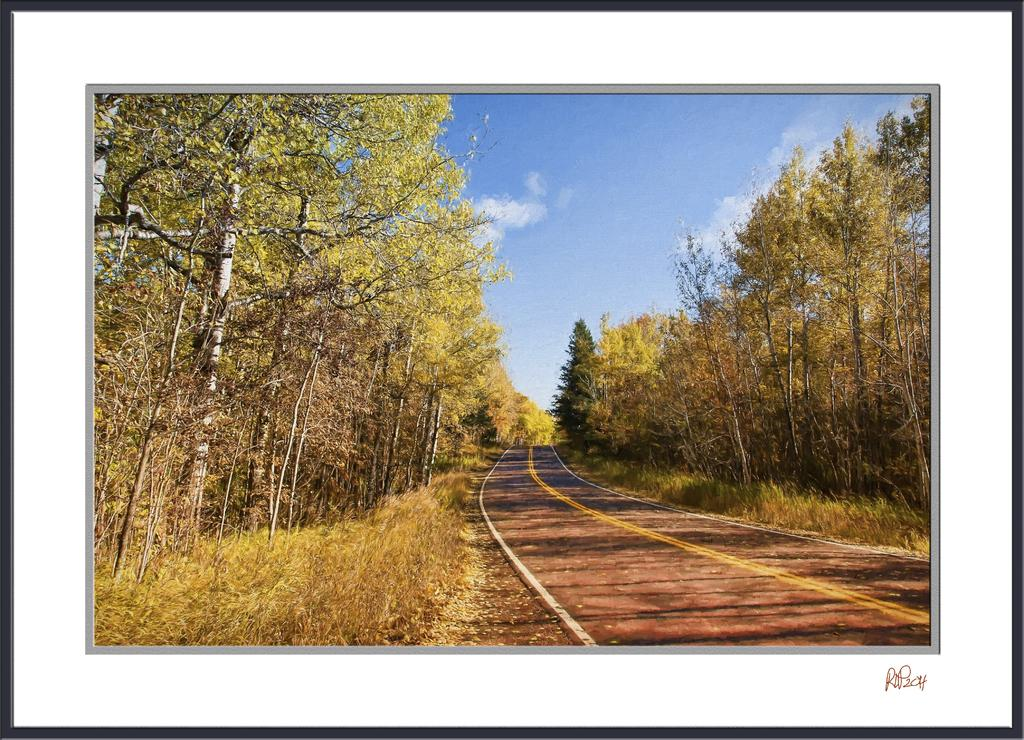What type of vegetation can be seen in the image? There are green color trees in the image. What else is present in the image besides the trees? There is a road in the image. What part of the natural environment is visible in the image? The sky is visible in the image. What type of lettuce can be seen growing on the road in the image? There is no lettuce present in the image, and the road is not a place where plants typically grow. 